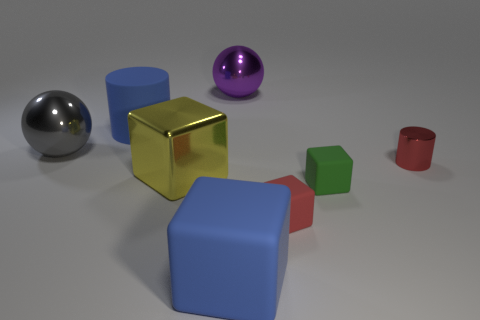Is the color of the large rubber cylinder the same as the big matte block?
Give a very brief answer. Yes. Is there a red rubber thing of the same shape as the yellow shiny thing?
Your answer should be very brief. Yes. What number of green things are big blocks or large objects?
Offer a terse response. 0. Are there any blue matte cubes of the same size as the yellow metal thing?
Offer a very short reply. Yes. What number of big blue blocks are there?
Give a very brief answer. 1. What number of big objects are either rubber cylinders or green objects?
Keep it short and to the point. 1. There is a ball that is left of the large rubber thing in front of the cylinder that is behind the red shiny thing; what is its color?
Make the answer very short. Gray. How many other things are the same color as the metallic cube?
Ensure brevity in your answer.  0. How many shiny objects are large brown spheres or gray objects?
Offer a very short reply. 1. Is the color of the cylinder that is in front of the big rubber cylinder the same as the small rubber block to the left of the green thing?
Keep it short and to the point. Yes. 